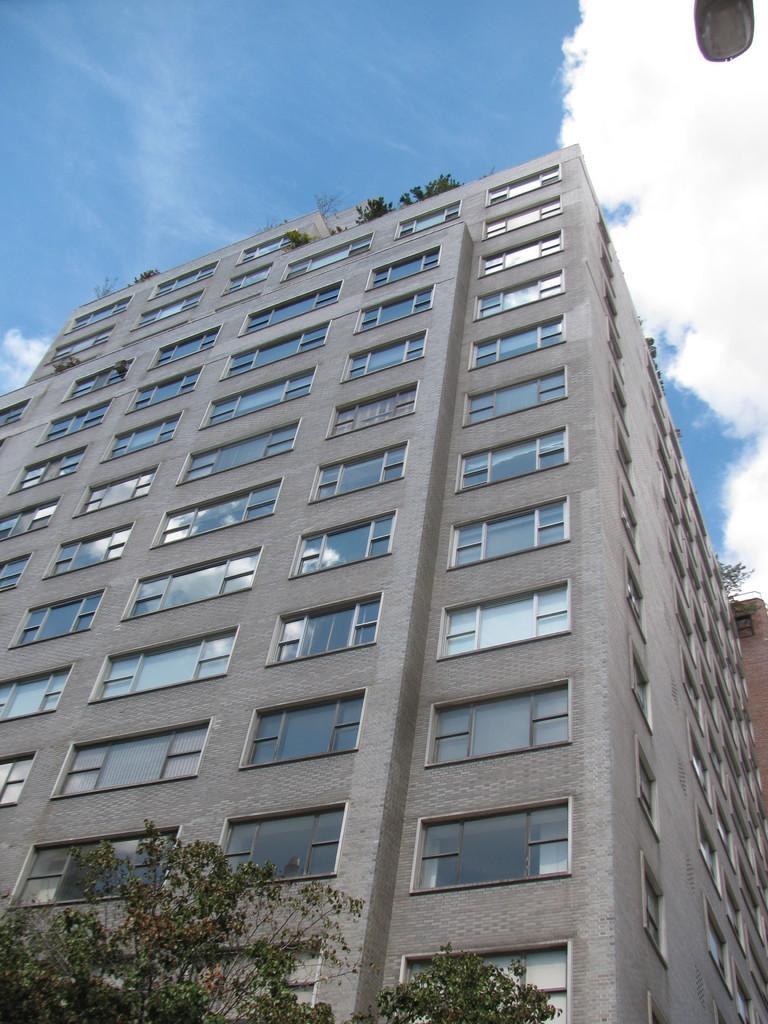Could you give a brief overview of what you see in this image? In this picture we can see a building, there is a tree at the bottom, we can see the sky and clouds at the top of the picture, it looks like a light at the right top of the picture. 